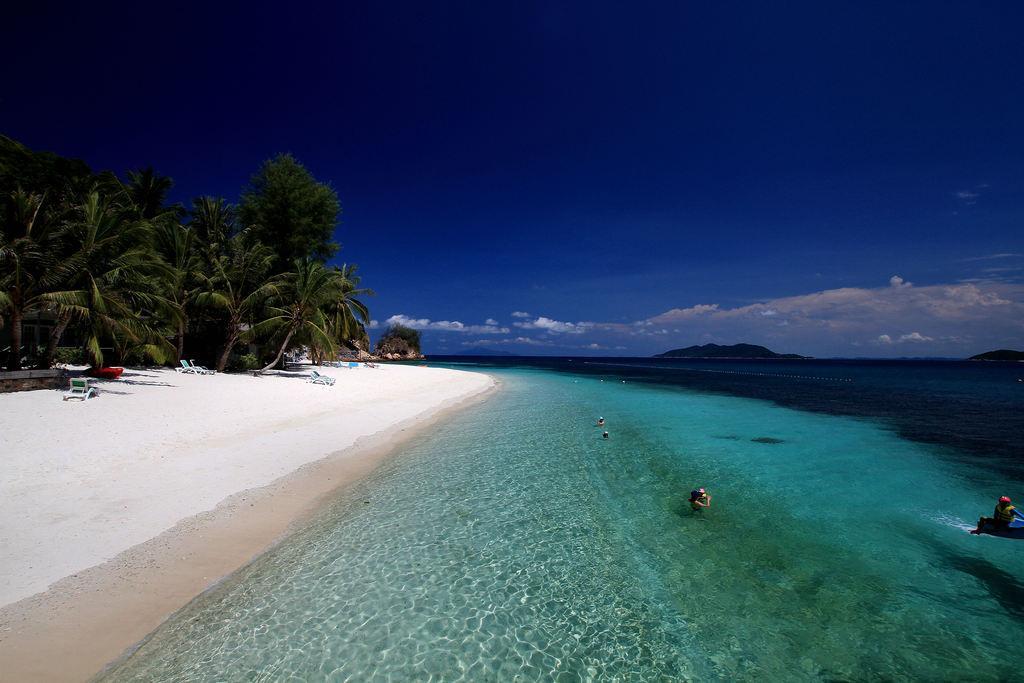Could you give a brief overview of what you see in this image? In this image there are a few people in the water. In front of the water, there is sand on the sand there are benches and some other objects, behind them there are trees. In the background of the image there are mountains. At the top of the image there are clouds in the sky. 